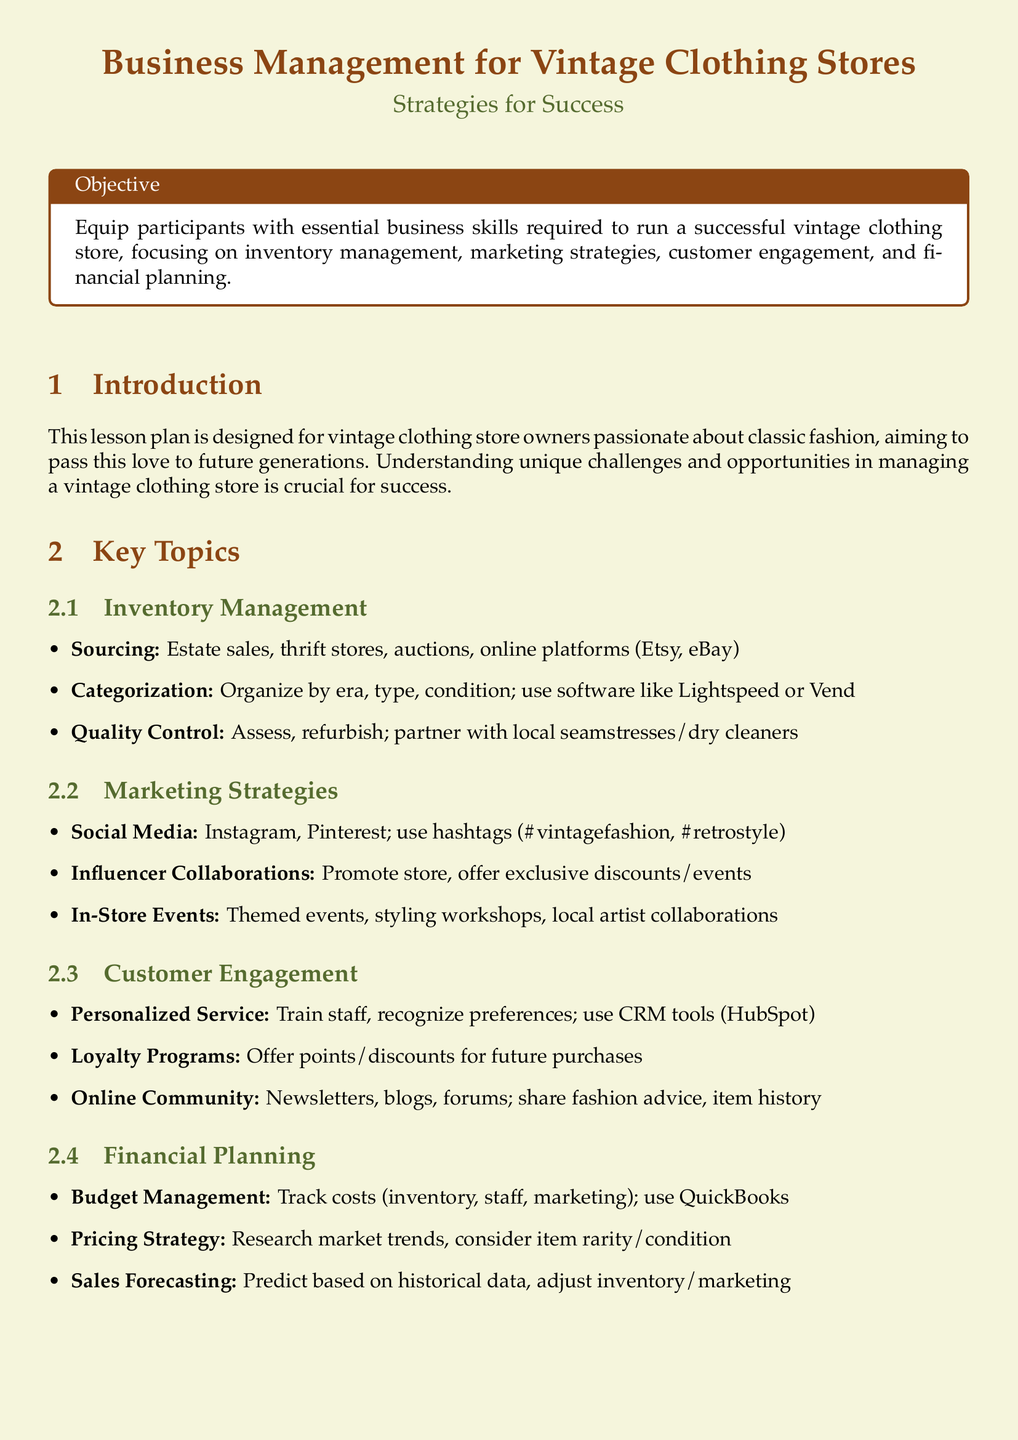What is the primary objective of the lesson plan? The objective is to equip participants with essential business skills required to run a successful vintage clothing store, focusing on inventory management, marketing strategies, customer engagement, and financial planning.
Answer: Equip participants with essential business skills required to run a successful vintage clothing store Which social media platforms are recommended for marketing? The document lists Instagram and Pinterest as the recommended social media platforms for marketing strategies.
Answer: Instagram, Pinterest What are two methods for sourcing inventory? The sourcing methods mentioned include estate sales and thrift stores, among others.
Answer: Estate sales, thrift stores What is one way to engage customers personally? The lesson plan emphasizes training staff to recognize customer preferences as a method of personalized service.
Answer: Train staff, recognize preferences Name a financial planning tool suggested in the document. The document recommends using QuickBooks for budget management.
Answer: QuickBooks What is a key aspect of financial planning mentioned? One key aspect highlighted is sales forecasting, which involves predicting based on historical data.
Answer: Sales forecasting Which resource is suggested for further reading? The document suggests the book "Vintage Fashion Complete" by Nicky Albrechtsen as a resource for further reading.
Answer: "Vintage Fashion Complete" by Nicky Albrechtsen What should be considered when developing a pricing strategy? The document states that market trends and item rarity/condition should be considered in pricing strategy.
Answer: Research market trends, consider item rarity/condition 